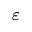<formula> <loc_0><loc_0><loc_500><loc_500>\varepsilon</formula> 